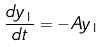<formula> <loc_0><loc_0><loc_500><loc_500>\frac { d y _ { 1 } } { d t } = - A y _ { 1 }</formula> 